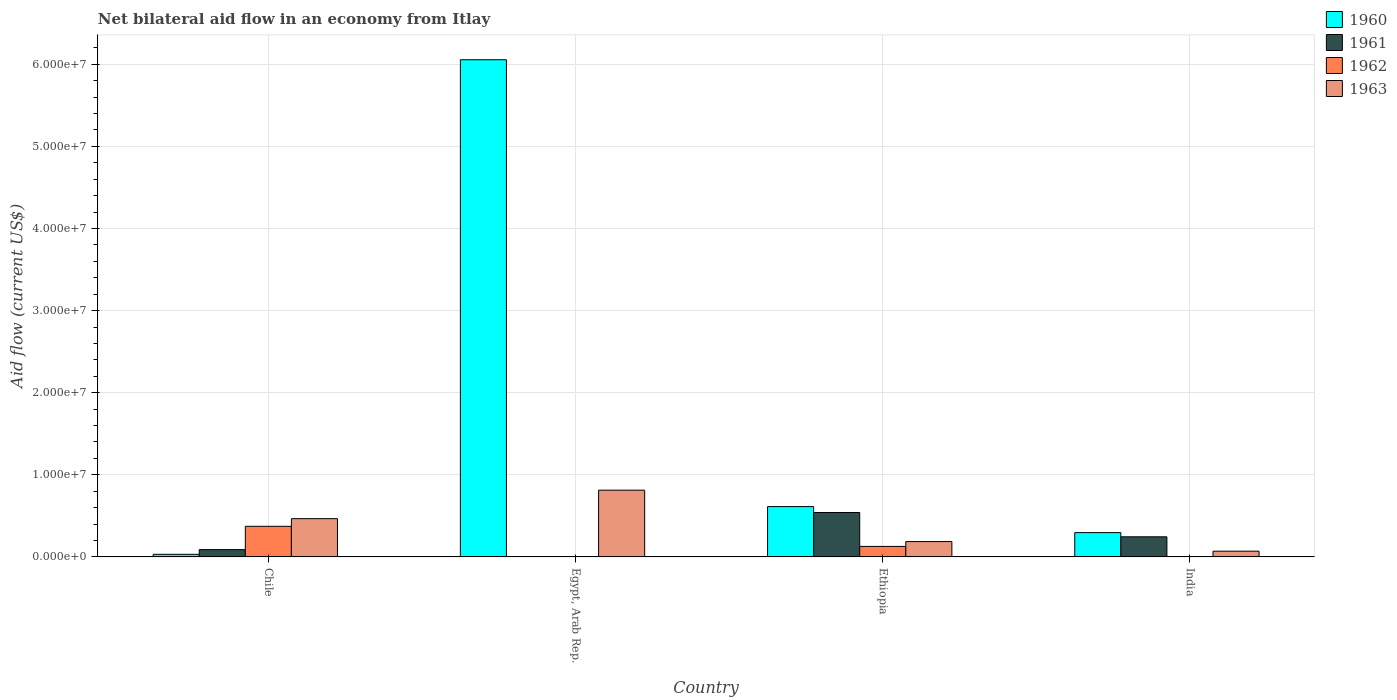How many different coloured bars are there?
Offer a very short reply. 4. How many groups of bars are there?
Your response must be concise. 4. Are the number of bars per tick equal to the number of legend labels?
Offer a terse response. No. Are the number of bars on each tick of the X-axis equal?
Offer a terse response. No. How many bars are there on the 4th tick from the right?
Your response must be concise. 4. What is the net bilateral aid flow in 1962 in Chile?
Provide a succinct answer. 3.73e+06. Across all countries, what is the maximum net bilateral aid flow in 1960?
Your answer should be compact. 6.06e+07. Across all countries, what is the minimum net bilateral aid flow in 1963?
Provide a short and direct response. 7.00e+05. In which country was the net bilateral aid flow in 1963 maximum?
Offer a very short reply. Egypt, Arab Rep. What is the total net bilateral aid flow in 1962 in the graph?
Provide a succinct answer. 5.01e+06. What is the difference between the net bilateral aid flow in 1960 in Egypt, Arab Rep. and that in India?
Provide a succinct answer. 5.76e+07. What is the difference between the net bilateral aid flow in 1960 in Ethiopia and the net bilateral aid flow in 1961 in Egypt, Arab Rep.?
Keep it short and to the point. 6.13e+06. What is the average net bilateral aid flow in 1962 per country?
Provide a succinct answer. 1.25e+06. What is the difference between the net bilateral aid flow of/in 1961 and net bilateral aid flow of/in 1960 in India?
Make the answer very short. -5.10e+05. What is the ratio of the net bilateral aid flow in 1963 in Chile to that in India?
Your answer should be compact. 6.66. Is the net bilateral aid flow in 1963 in Ethiopia less than that in India?
Offer a very short reply. No. What is the difference between the highest and the second highest net bilateral aid flow in 1963?
Give a very brief answer. 3.47e+06. What is the difference between the highest and the lowest net bilateral aid flow in 1961?
Your answer should be very brief. 5.41e+06. Is the sum of the net bilateral aid flow in 1960 in Chile and Egypt, Arab Rep. greater than the maximum net bilateral aid flow in 1962 across all countries?
Provide a short and direct response. Yes. Is it the case that in every country, the sum of the net bilateral aid flow in 1960 and net bilateral aid flow in 1962 is greater than the sum of net bilateral aid flow in 1961 and net bilateral aid flow in 1963?
Your answer should be compact. No. What is the difference between two consecutive major ticks on the Y-axis?
Ensure brevity in your answer.  1.00e+07. Are the values on the major ticks of Y-axis written in scientific E-notation?
Your answer should be very brief. Yes. Does the graph contain any zero values?
Provide a short and direct response. Yes. Does the graph contain grids?
Your answer should be compact. Yes. How many legend labels are there?
Ensure brevity in your answer.  4. How are the legend labels stacked?
Offer a terse response. Vertical. What is the title of the graph?
Provide a succinct answer. Net bilateral aid flow in an economy from Itlay. Does "2008" appear as one of the legend labels in the graph?
Your answer should be compact. No. What is the label or title of the Y-axis?
Keep it short and to the point. Aid flow (current US$). What is the Aid flow (current US$) in 1961 in Chile?
Provide a succinct answer. 8.90e+05. What is the Aid flow (current US$) of 1962 in Chile?
Make the answer very short. 3.73e+06. What is the Aid flow (current US$) in 1963 in Chile?
Offer a terse response. 4.66e+06. What is the Aid flow (current US$) in 1960 in Egypt, Arab Rep.?
Your answer should be compact. 6.06e+07. What is the Aid flow (current US$) of 1963 in Egypt, Arab Rep.?
Provide a short and direct response. 8.13e+06. What is the Aid flow (current US$) in 1960 in Ethiopia?
Your answer should be very brief. 6.13e+06. What is the Aid flow (current US$) in 1961 in Ethiopia?
Your answer should be compact. 5.41e+06. What is the Aid flow (current US$) in 1962 in Ethiopia?
Ensure brevity in your answer.  1.28e+06. What is the Aid flow (current US$) in 1963 in Ethiopia?
Make the answer very short. 1.87e+06. What is the Aid flow (current US$) of 1960 in India?
Offer a very short reply. 2.96e+06. What is the Aid flow (current US$) in 1961 in India?
Provide a succinct answer. 2.45e+06. Across all countries, what is the maximum Aid flow (current US$) of 1960?
Provide a short and direct response. 6.06e+07. Across all countries, what is the maximum Aid flow (current US$) in 1961?
Your answer should be very brief. 5.41e+06. Across all countries, what is the maximum Aid flow (current US$) of 1962?
Offer a terse response. 3.73e+06. Across all countries, what is the maximum Aid flow (current US$) of 1963?
Your answer should be compact. 8.13e+06. Across all countries, what is the minimum Aid flow (current US$) of 1961?
Offer a terse response. 0. What is the total Aid flow (current US$) of 1960 in the graph?
Provide a short and direct response. 7.00e+07. What is the total Aid flow (current US$) in 1961 in the graph?
Provide a short and direct response. 8.75e+06. What is the total Aid flow (current US$) of 1962 in the graph?
Provide a short and direct response. 5.01e+06. What is the total Aid flow (current US$) in 1963 in the graph?
Keep it short and to the point. 1.54e+07. What is the difference between the Aid flow (current US$) of 1960 in Chile and that in Egypt, Arab Rep.?
Provide a succinct answer. -6.02e+07. What is the difference between the Aid flow (current US$) of 1963 in Chile and that in Egypt, Arab Rep.?
Your response must be concise. -3.47e+06. What is the difference between the Aid flow (current US$) of 1960 in Chile and that in Ethiopia?
Ensure brevity in your answer.  -5.81e+06. What is the difference between the Aid flow (current US$) of 1961 in Chile and that in Ethiopia?
Your response must be concise. -4.52e+06. What is the difference between the Aid flow (current US$) in 1962 in Chile and that in Ethiopia?
Your answer should be compact. 2.45e+06. What is the difference between the Aid flow (current US$) of 1963 in Chile and that in Ethiopia?
Provide a succinct answer. 2.79e+06. What is the difference between the Aid flow (current US$) of 1960 in Chile and that in India?
Give a very brief answer. -2.64e+06. What is the difference between the Aid flow (current US$) of 1961 in Chile and that in India?
Offer a terse response. -1.56e+06. What is the difference between the Aid flow (current US$) of 1963 in Chile and that in India?
Keep it short and to the point. 3.96e+06. What is the difference between the Aid flow (current US$) of 1960 in Egypt, Arab Rep. and that in Ethiopia?
Provide a short and direct response. 5.44e+07. What is the difference between the Aid flow (current US$) in 1963 in Egypt, Arab Rep. and that in Ethiopia?
Ensure brevity in your answer.  6.26e+06. What is the difference between the Aid flow (current US$) in 1960 in Egypt, Arab Rep. and that in India?
Your response must be concise. 5.76e+07. What is the difference between the Aid flow (current US$) in 1963 in Egypt, Arab Rep. and that in India?
Ensure brevity in your answer.  7.43e+06. What is the difference between the Aid flow (current US$) of 1960 in Ethiopia and that in India?
Your response must be concise. 3.17e+06. What is the difference between the Aid flow (current US$) of 1961 in Ethiopia and that in India?
Ensure brevity in your answer.  2.96e+06. What is the difference between the Aid flow (current US$) in 1963 in Ethiopia and that in India?
Offer a terse response. 1.17e+06. What is the difference between the Aid flow (current US$) in 1960 in Chile and the Aid flow (current US$) in 1963 in Egypt, Arab Rep.?
Give a very brief answer. -7.81e+06. What is the difference between the Aid flow (current US$) of 1961 in Chile and the Aid flow (current US$) of 1963 in Egypt, Arab Rep.?
Ensure brevity in your answer.  -7.24e+06. What is the difference between the Aid flow (current US$) in 1962 in Chile and the Aid flow (current US$) in 1963 in Egypt, Arab Rep.?
Ensure brevity in your answer.  -4.40e+06. What is the difference between the Aid flow (current US$) of 1960 in Chile and the Aid flow (current US$) of 1961 in Ethiopia?
Keep it short and to the point. -5.09e+06. What is the difference between the Aid flow (current US$) of 1960 in Chile and the Aid flow (current US$) of 1962 in Ethiopia?
Provide a short and direct response. -9.60e+05. What is the difference between the Aid flow (current US$) of 1960 in Chile and the Aid flow (current US$) of 1963 in Ethiopia?
Your answer should be compact. -1.55e+06. What is the difference between the Aid flow (current US$) of 1961 in Chile and the Aid flow (current US$) of 1962 in Ethiopia?
Keep it short and to the point. -3.90e+05. What is the difference between the Aid flow (current US$) of 1961 in Chile and the Aid flow (current US$) of 1963 in Ethiopia?
Your answer should be very brief. -9.80e+05. What is the difference between the Aid flow (current US$) in 1962 in Chile and the Aid flow (current US$) in 1963 in Ethiopia?
Offer a terse response. 1.86e+06. What is the difference between the Aid flow (current US$) of 1960 in Chile and the Aid flow (current US$) of 1961 in India?
Provide a succinct answer. -2.13e+06. What is the difference between the Aid flow (current US$) in 1960 in Chile and the Aid flow (current US$) in 1963 in India?
Offer a terse response. -3.80e+05. What is the difference between the Aid flow (current US$) of 1962 in Chile and the Aid flow (current US$) of 1963 in India?
Your answer should be compact. 3.03e+06. What is the difference between the Aid flow (current US$) in 1960 in Egypt, Arab Rep. and the Aid flow (current US$) in 1961 in Ethiopia?
Offer a terse response. 5.51e+07. What is the difference between the Aid flow (current US$) in 1960 in Egypt, Arab Rep. and the Aid flow (current US$) in 1962 in Ethiopia?
Offer a very short reply. 5.93e+07. What is the difference between the Aid flow (current US$) of 1960 in Egypt, Arab Rep. and the Aid flow (current US$) of 1963 in Ethiopia?
Your response must be concise. 5.87e+07. What is the difference between the Aid flow (current US$) of 1960 in Egypt, Arab Rep. and the Aid flow (current US$) of 1961 in India?
Keep it short and to the point. 5.81e+07. What is the difference between the Aid flow (current US$) in 1960 in Egypt, Arab Rep. and the Aid flow (current US$) in 1963 in India?
Your answer should be very brief. 5.98e+07. What is the difference between the Aid flow (current US$) of 1960 in Ethiopia and the Aid flow (current US$) of 1961 in India?
Your response must be concise. 3.68e+06. What is the difference between the Aid flow (current US$) in 1960 in Ethiopia and the Aid flow (current US$) in 1963 in India?
Provide a short and direct response. 5.43e+06. What is the difference between the Aid flow (current US$) of 1961 in Ethiopia and the Aid flow (current US$) of 1963 in India?
Offer a terse response. 4.71e+06. What is the difference between the Aid flow (current US$) of 1962 in Ethiopia and the Aid flow (current US$) of 1963 in India?
Your response must be concise. 5.80e+05. What is the average Aid flow (current US$) of 1960 per country?
Give a very brief answer. 1.75e+07. What is the average Aid flow (current US$) of 1961 per country?
Ensure brevity in your answer.  2.19e+06. What is the average Aid flow (current US$) in 1962 per country?
Provide a succinct answer. 1.25e+06. What is the average Aid flow (current US$) of 1963 per country?
Keep it short and to the point. 3.84e+06. What is the difference between the Aid flow (current US$) in 1960 and Aid flow (current US$) in 1961 in Chile?
Provide a succinct answer. -5.70e+05. What is the difference between the Aid flow (current US$) of 1960 and Aid flow (current US$) of 1962 in Chile?
Keep it short and to the point. -3.41e+06. What is the difference between the Aid flow (current US$) of 1960 and Aid flow (current US$) of 1963 in Chile?
Ensure brevity in your answer.  -4.34e+06. What is the difference between the Aid flow (current US$) of 1961 and Aid flow (current US$) of 1962 in Chile?
Offer a very short reply. -2.84e+06. What is the difference between the Aid flow (current US$) in 1961 and Aid flow (current US$) in 1963 in Chile?
Provide a short and direct response. -3.77e+06. What is the difference between the Aid flow (current US$) in 1962 and Aid flow (current US$) in 1963 in Chile?
Your answer should be very brief. -9.30e+05. What is the difference between the Aid flow (current US$) in 1960 and Aid flow (current US$) in 1963 in Egypt, Arab Rep.?
Your answer should be compact. 5.24e+07. What is the difference between the Aid flow (current US$) in 1960 and Aid flow (current US$) in 1961 in Ethiopia?
Make the answer very short. 7.20e+05. What is the difference between the Aid flow (current US$) of 1960 and Aid flow (current US$) of 1962 in Ethiopia?
Ensure brevity in your answer.  4.85e+06. What is the difference between the Aid flow (current US$) in 1960 and Aid flow (current US$) in 1963 in Ethiopia?
Provide a succinct answer. 4.26e+06. What is the difference between the Aid flow (current US$) in 1961 and Aid flow (current US$) in 1962 in Ethiopia?
Ensure brevity in your answer.  4.13e+06. What is the difference between the Aid flow (current US$) in 1961 and Aid flow (current US$) in 1963 in Ethiopia?
Offer a very short reply. 3.54e+06. What is the difference between the Aid flow (current US$) in 1962 and Aid flow (current US$) in 1963 in Ethiopia?
Offer a very short reply. -5.90e+05. What is the difference between the Aid flow (current US$) in 1960 and Aid flow (current US$) in 1961 in India?
Your answer should be very brief. 5.10e+05. What is the difference between the Aid flow (current US$) of 1960 and Aid flow (current US$) of 1963 in India?
Keep it short and to the point. 2.26e+06. What is the difference between the Aid flow (current US$) in 1961 and Aid flow (current US$) in 1963 in India?
Provide a short and direct response. 1.75e+06. What is the ratio of the Aid flow (current US$) of 1960 in Chile to that in Egypt, Arab Rep.?
Keep it short and to the point. 0.01. What is the ratio of the Aid flow (current US$) of 1963 in Chile to that in Egypt, Arab Rep.?
Ensure brevity in your answer.  0.57. What is the ratio of the Aid flow (current US$) of 1960 in Chile to that in Ethiopia?
Offer a very short reply. 0.05. What is the ratio of the Aid flow (current US$) in 1961 in Chile to that in Ethiopia?
Ensure brevity in your answer.  0.16. What is the ratio of the Aid flow (current US$) of 1962 in Chile to that in Ethiopia?
Your answer should be compact. 2.91. What is the ratio of the Aid flow (current US$) in 1963 in Chile to that in Ethiopia?
Keep it short and to the point. 2.49. What is the ratio of the Aid flow (current US$) of 1960 in Chile to that in India?
Keep it short and to the point. 0.11. What is the ratio of the Aid flow (current US$) of 1961 in Chile to that in India?
Make the answer very short. 0.36. What is the ratio of the Aid flow (current US$) in 1963 in Chile to that in India?
Give a very brief answer. 6.66. What is the ratio of the Aid flow (current US$) in 1960 in Egypt, Arab Rep. to that in Ethiopia?
Offer a terse response. 9.88. What is the ratio of the Aid flow (current US$) of 1963 in Egypt, Arab Rep. to that in Ethiopia?
Offer a very short reply. 4.35. What is the ratio of the Aid flow (current US$) in 1960 in Egypt, Arab Rep. to that in India?
Make the answer very short. 20.46. What is the ratio of the Aid flow (current US$) in 1963 in Egypt, Arab Rep. to that in India?
Your answer should be compact. 11.61. What is the ratio of the Aid flow (current US$) in 1960 in Ethiopia to that in India?
Your answer should be very brief. 2.07. What is the ratio of the Aid flow (current US$) in 1961 in Ethiopia to that in India?
Your answer should be compact. 2.21. What is the ratio of the Aid flow (current US$) of 1963 in Ethiopia to that in India?
Your answer should be compact. 2.67. What is the difference between the highest and the second highest Aid flow (current US$) in 1960?
Your answer should be compact. 5.44e+07. What is the difference between the highest and the second highest Aid flow (current US$) in 1961?
Your answer should be compact. 2.96e+06. What is the difference between the highest and the second highest Aid flow (current US$) in 1963?
Provide a succinct answer. 3.47e+06. What is the difference between the highest and the lowest Aid flow (current US$) of 1960?
Offer a terse response. 6.02e+07. What is the difference between the highest and the lowest Aid flow (current US$) in 1961?
Your answer should be very brief. 5.41e+06. What is the difference between the highest and the lowest Aid flow (current US$) of 1962?
Provide a succinct answer. 3.73e+06. What is the difference between the highest and the lowest Aid flow (current US$) of 1963?
Your response must be concise. 7.43e+06. 